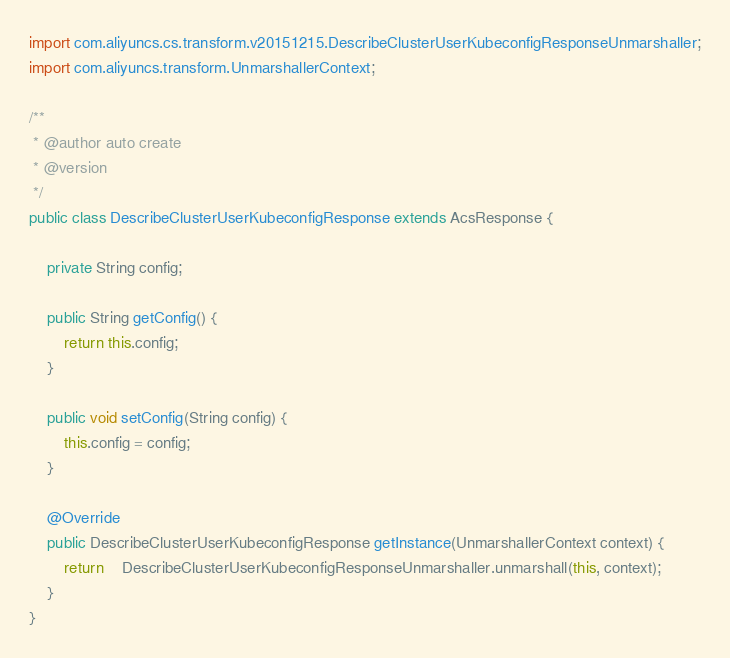Convert code to text. <code><loc_0><loc_0><loc_500><loc_500><_Java_>import com.aliyuncs.cs.transform.v20151215.DescribeClusterUserKubeconfigResponseUnmarshaller;
import com.aliyuncs.transform.UnmarshallerContext;

/**
 * @author auto create
 * @version 
 */
public class DescribeClusterUserKubeconfigResponse extends AcsResponse {

	private String config;

	public String getConfig() {
		return this.config;
	}

	public void setConfig(String config) {
		this.config = config;
	}

	@Override
	public DescribeClusterUserKubeconfigResponse getInstance(UnmarshallerContext context) {
		return	DescribeClusterUserKubeconfigResponseUnmarshaller.unmarshall(this, context);
	}
}
</code> 